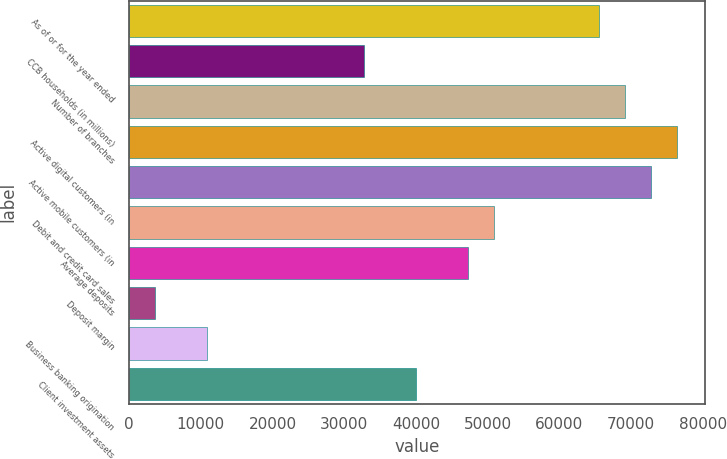<chart> <loc_0><loc_0><loc_500><loc_500><bar_chart><fcel>As of or for the year ended<fcel>CCB households (in millions)<fcel>Number of branches<fcel>Active digital customers (in<fcel>Active mobile customers (in<fcel>Debit and credit card sales<fcel>Average deposits<fcel>Deposit margin<fcel>Business banking origination<fcel>Client investment assets<nl><fcel>65512<fcel>32756.5<fcel>69151.5<fcel>76430.5<fcel>72791<fcel>50954<fcel>47314.5<fcel>3640.48<fcel>10919.5<fcel>40035.5<nl></chart> 